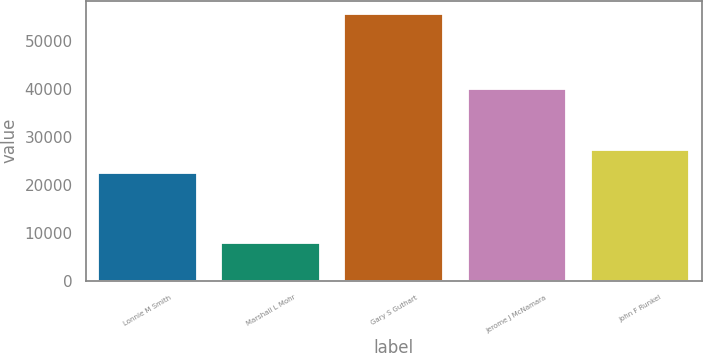<chart> <loc_0><loc_0><loc_500><loc_500><bar_chart><fcel>Lonnie M Smith<fcel>Marshall L Mohr<fcel>Gary S Guthart<fcel>Jerome J McNamara<fcel>John F Runkel<nl><fcel>22500<fcel>8000<fcel>55750<fcel>40160<fcel>27275<nl></chart> 